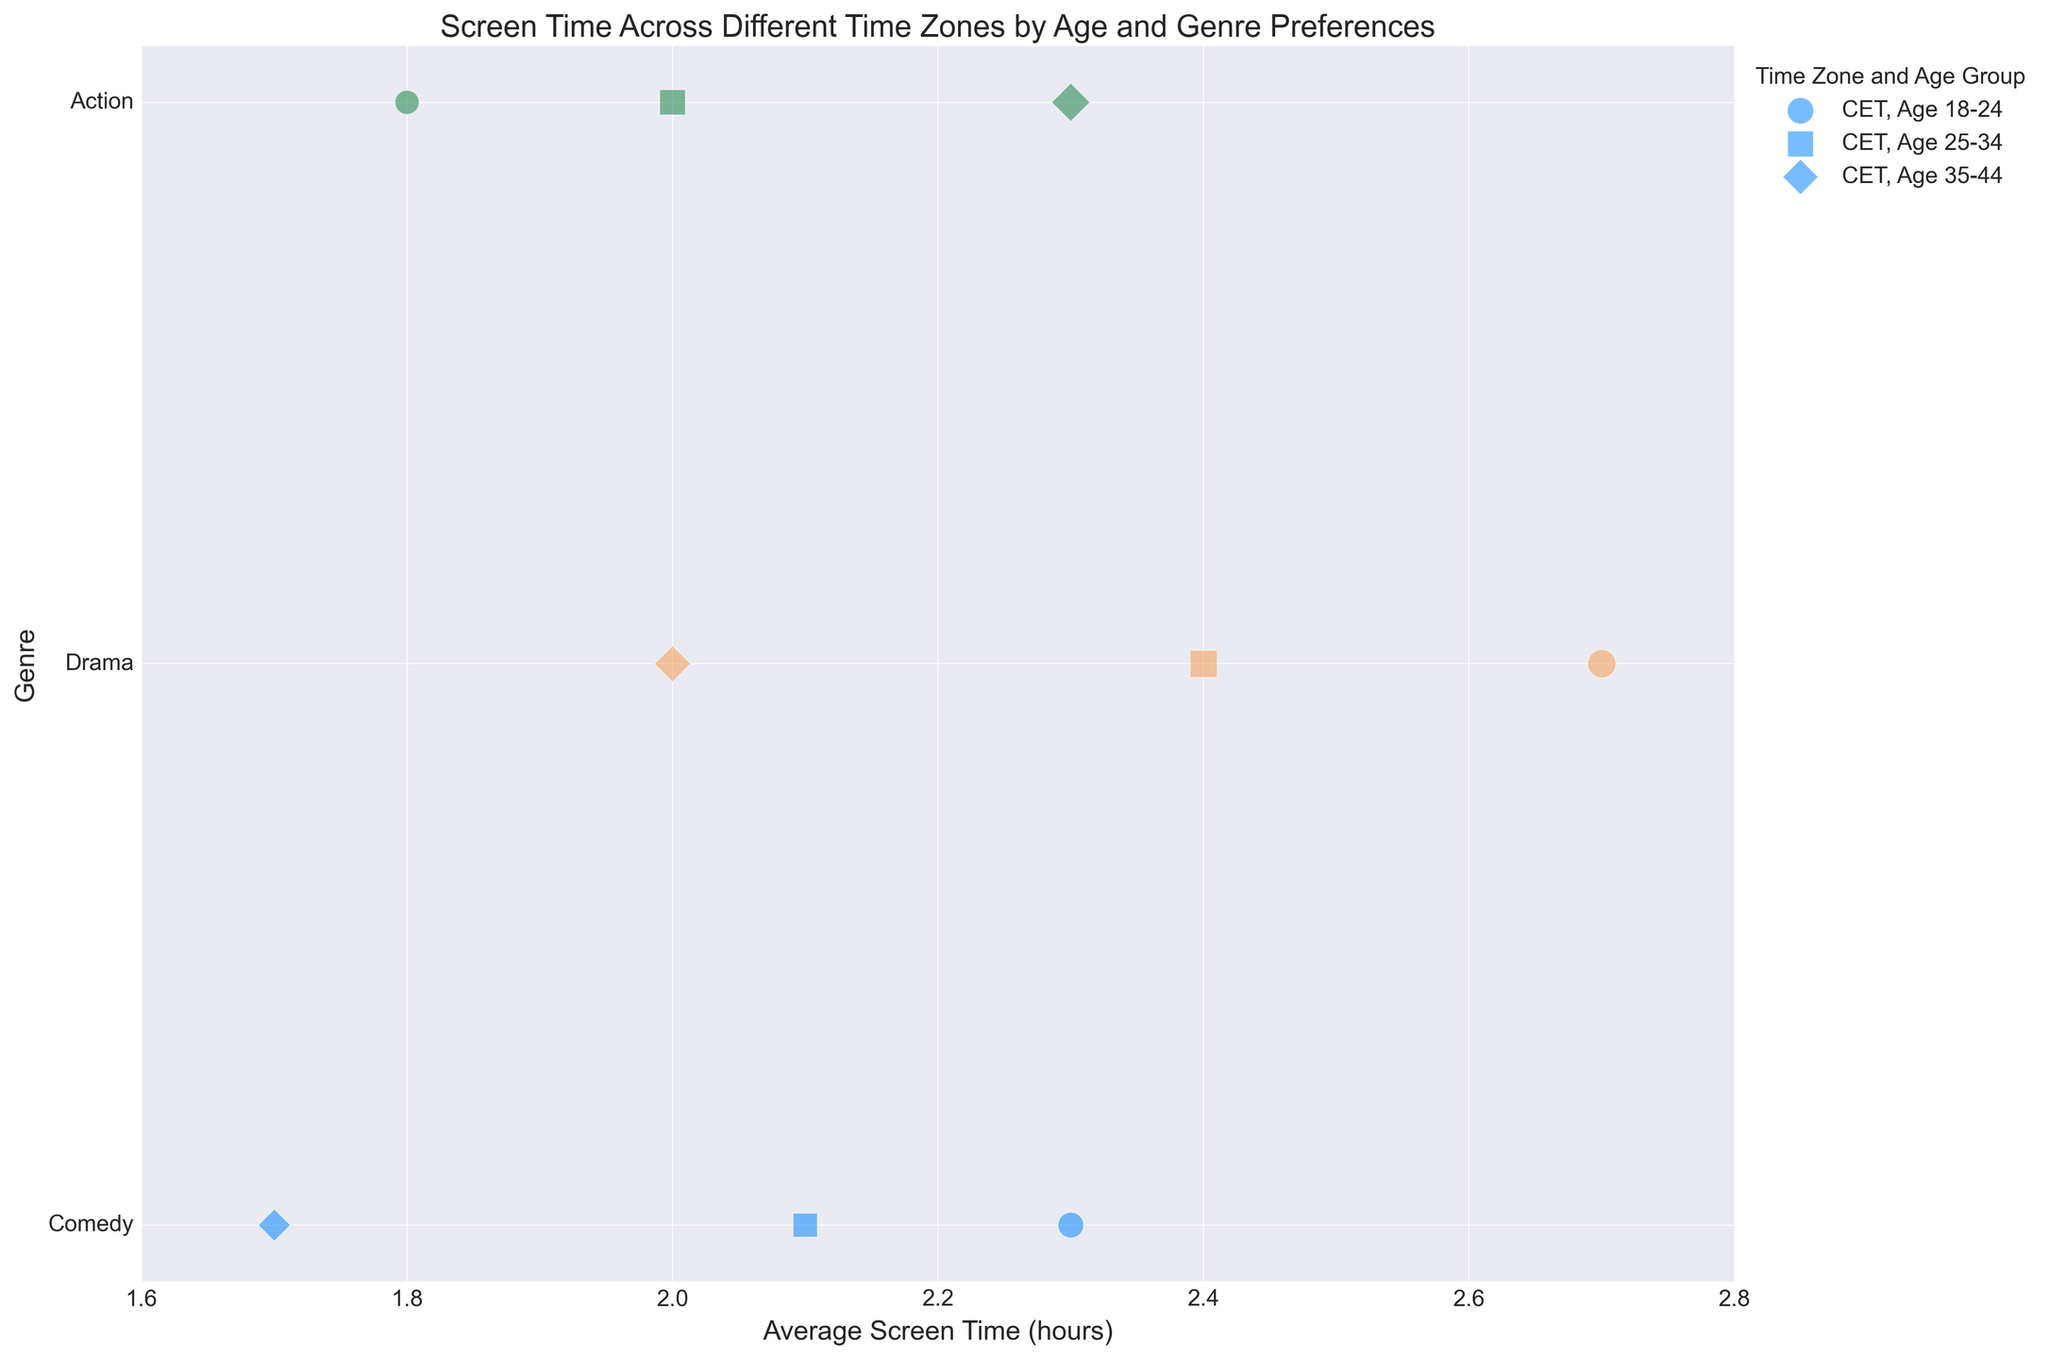What timezone has the highest average screen time for the Action genre for the 18-24 age group? Look at the Action genre markers for the 18-24 age group in each timezone. Compare the x-axis values. PST has 1.5, EST has 1.5, CET has 1.8, and IST has 1.9.
Answer: IST Which age group in the PST timezone has the smallest bubble size for the Drama genre? Look at the Drama genre markers in the PST timezone. Compare the bubble sizes (12 for 18-24, 11 for 25-34, and 9 for 35-44). The smallest bubble size is for the 35-44 age group.
Answer: 35-44 Do Comedy and Drama genres in the CET timezone for the 25-34 age group have the same average screen time? Check the x-axis values for Comedy and Drama genres in the CET timezone for the 25-34 age group. Comedy has an average screen time of 2.1 hours, and Drama has 2.4 hours.
Answer: No Which timezone has the most consistent (least variation in) screen time for Comedy across all age groups? Examine the x-axis variation in the Comedy genre for each timezone. PST has 2.5, 2.0, 1.5; EST has 2.0, 1.8, 1.3; CET has 2.3, 2.1, 1.7; IST has 2.4, 2.2, 1.6. The smallest range is in EST (difference of 0.7).
Answer: EST What is the combined bubble size for Action genre in the PST timezone across all age groups? Add the bubble sizes for Action genre in PST across 18-24, 25-34, and 35-44 age groups. Sizes are 8, 9, and 10. The sum is 8 + 9 + 10 = 27.
Answer: 27 In the EST timezone, which genre has the smallest average screen time for the 35-44 age group? Compare the x-axis values for each genre in EST for the 35-44 age group. Comedy has 1.3, Drama has 1.8, and Action has 2.1. The smallest value is for Comedy.
Answer: Comedy Which age group in the IST timezone watches Drama for the longest average time? Look at the Drama genre markers in the IST timezone. Compare the x-axis values (18-24: 2.6, 25-34: 2.3, 35-44: 1.9). The highest value is for the 18-24 age group.
Answer: 18-24 